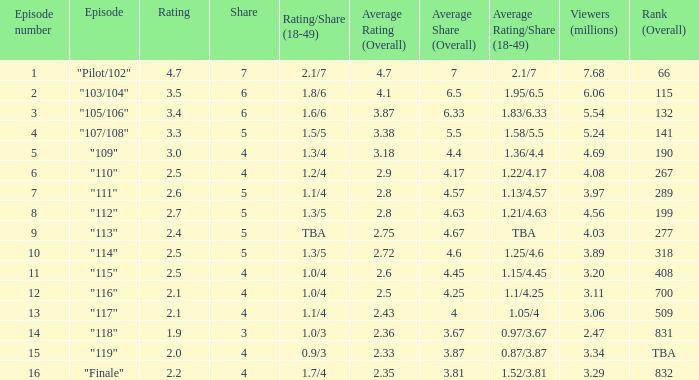WHAT IS THE RATING THAT HAD A SHARE SMALLER THAN 4, AND 2.47 MILLION VIEWERS? 0.0. 